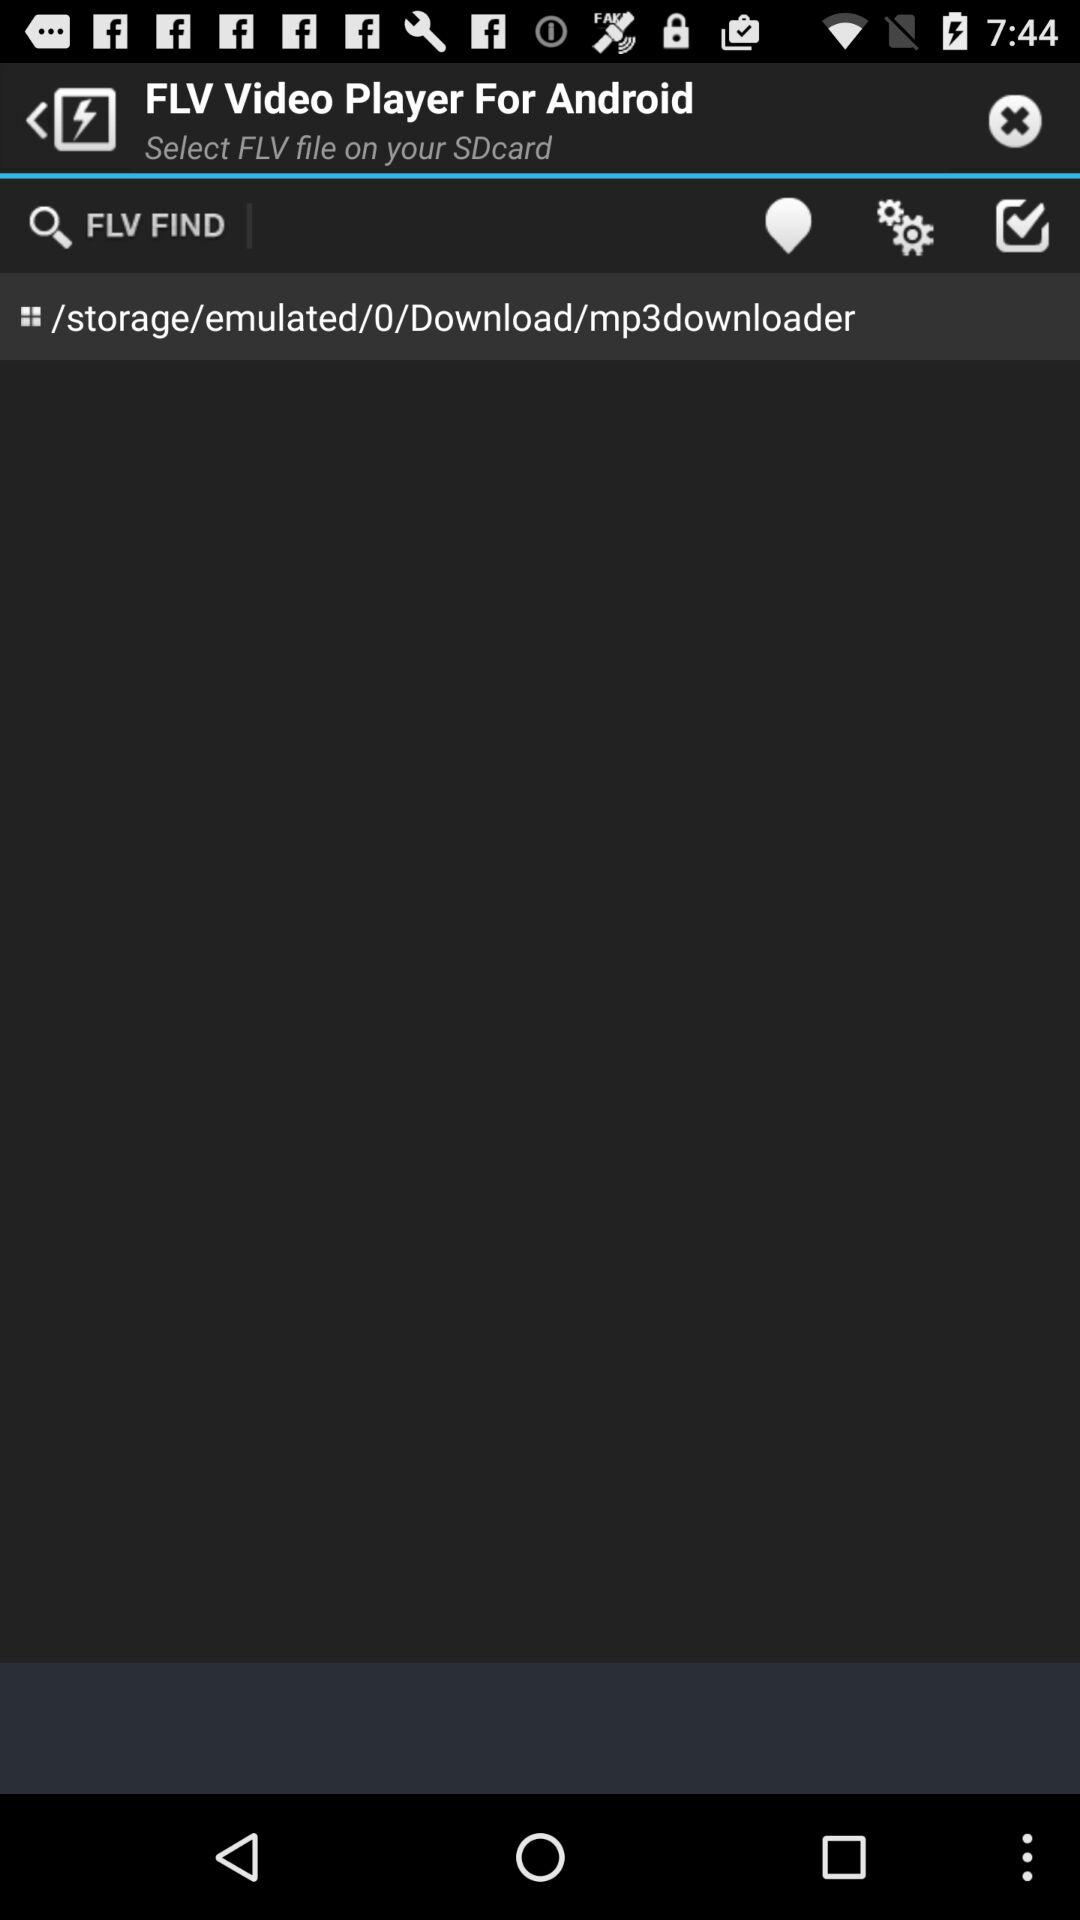What is the application name? The application name is "FLV Video Player For Android". 